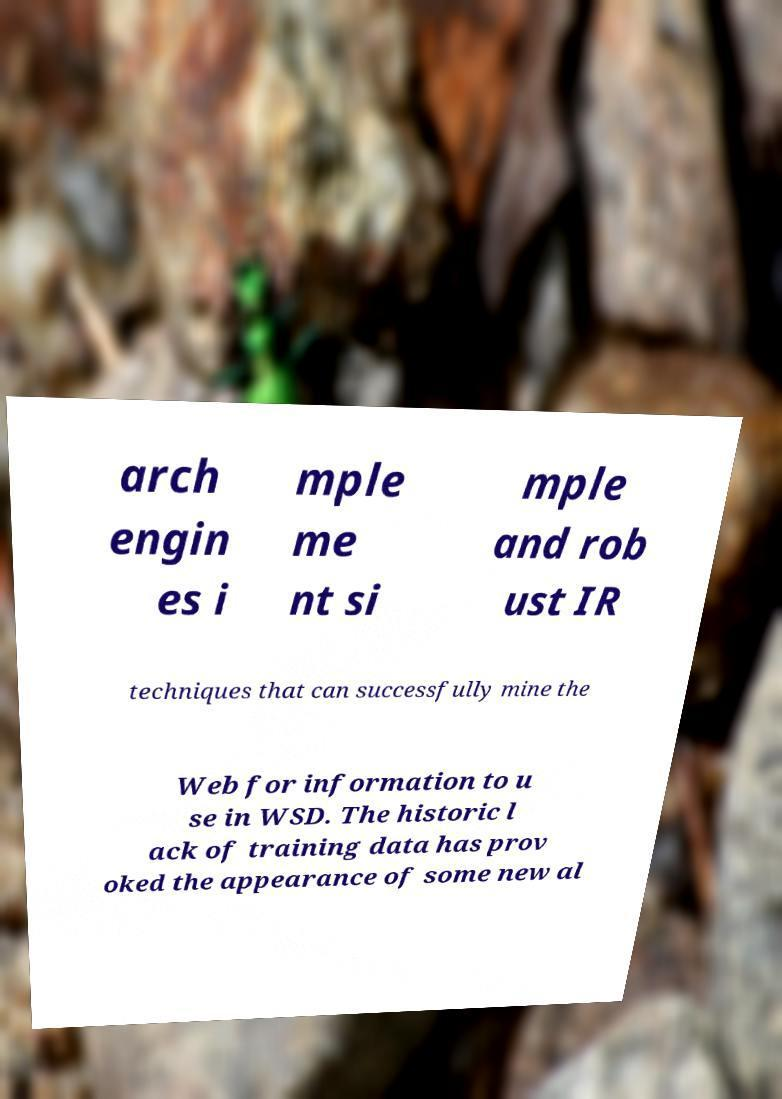What messages or text are displayed in this image? I need them in a readable, typed format. arch engin es i mple me nt si mple and rob ust IR techniques that can successfully mine the Web for information to u se in WSD. The historic l ack of training data has prov oked the appearance of some new al 